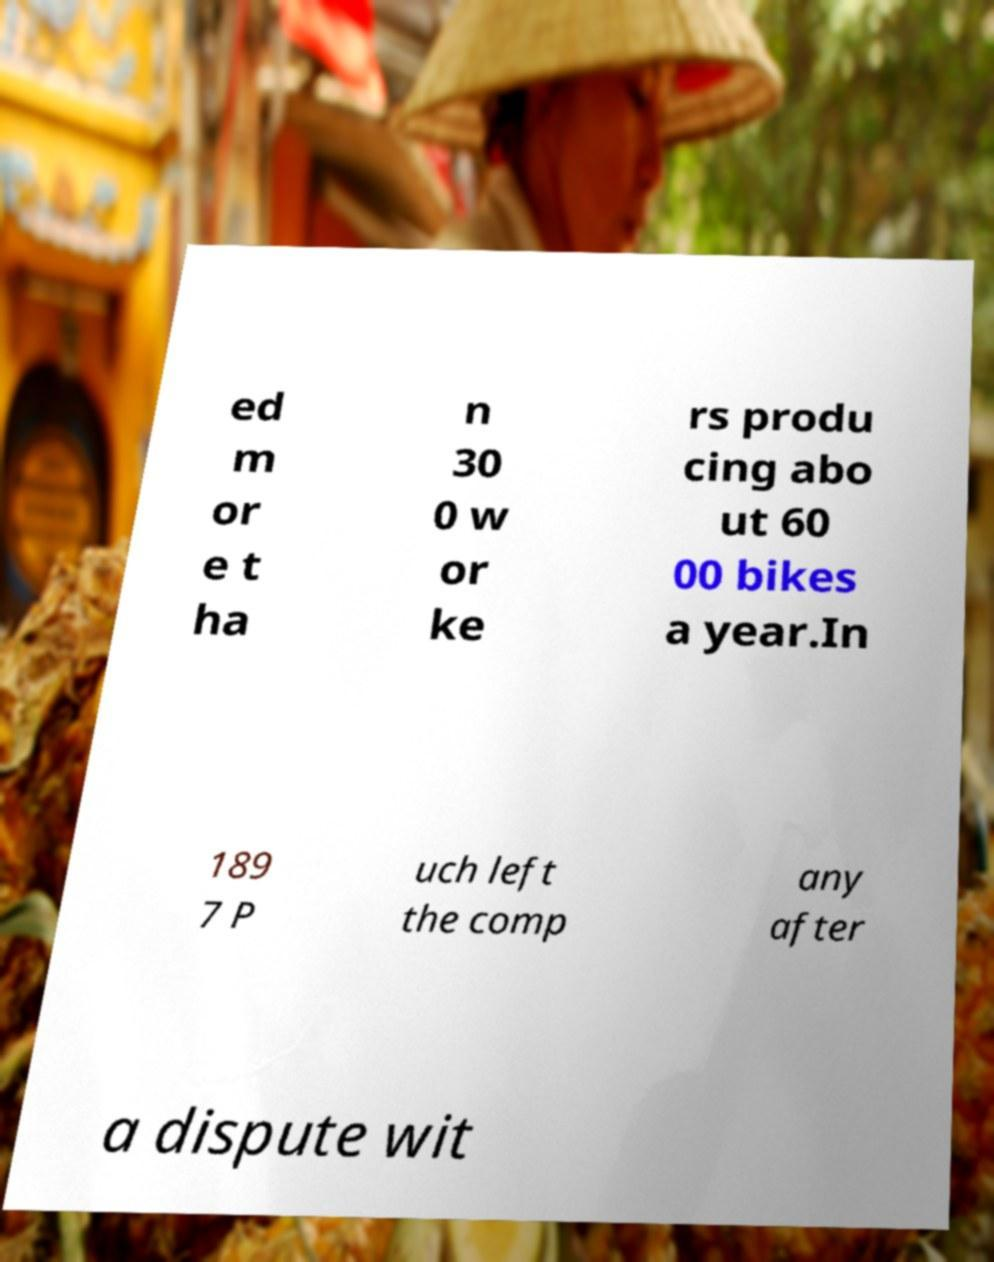Can you accurately transcribe the text from the provided image for me? ed m or e t ha n 30 0 w or ke rs produ cing abo ut 60 00 bikes a year.In 189 7 P uch left the comp any after a dispute wit 